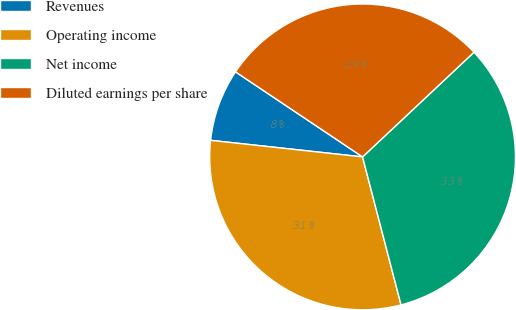<chart> <loc_0><loc_0><loc_500><loc_500><pie_chart><fcel>Revenues<fcel>Operating income<fcel>Net income<fcel>Diluted earnings per share<nl><fcel>7.66%<fcel>30.78%<fcel>32.96%<fcel>28.61%<nl></chart> 